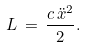Convert formula to latex. <formula><loc_0><loc_0><loc_500><loc_500>L \, = \, \frac { c \, \ddot { x } ^ { 2 } } { 2 } .</formula> 